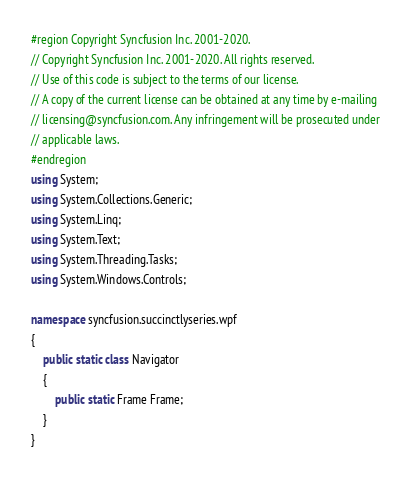Convert code to text. <code><loc_0><loc_0><loc_500><loc_500><_C#_>#region Copyright Syncfusion Inc. 2001-2020.
// Copyright Syncfusion Inc. 2001-2020. All rights reserved.
// Use of this code is subject to the terms of our license.
// A copy of the current license can be obtained at any time by e-mailing
// licensing@syncfusion.com. Any infringement will be prosecuted under
// applicable laws. 
#endregion
using System;
using System.Collections.Generic;
using System.Linq;
using System.Text;
using System.Threading.Tasks;
using System.Windows.Controls;

namespace syncfusion.succinctlyseries.wpf
{
    public static class Navigator
    {
        public static Frame Frame;
    }
}
</code> 